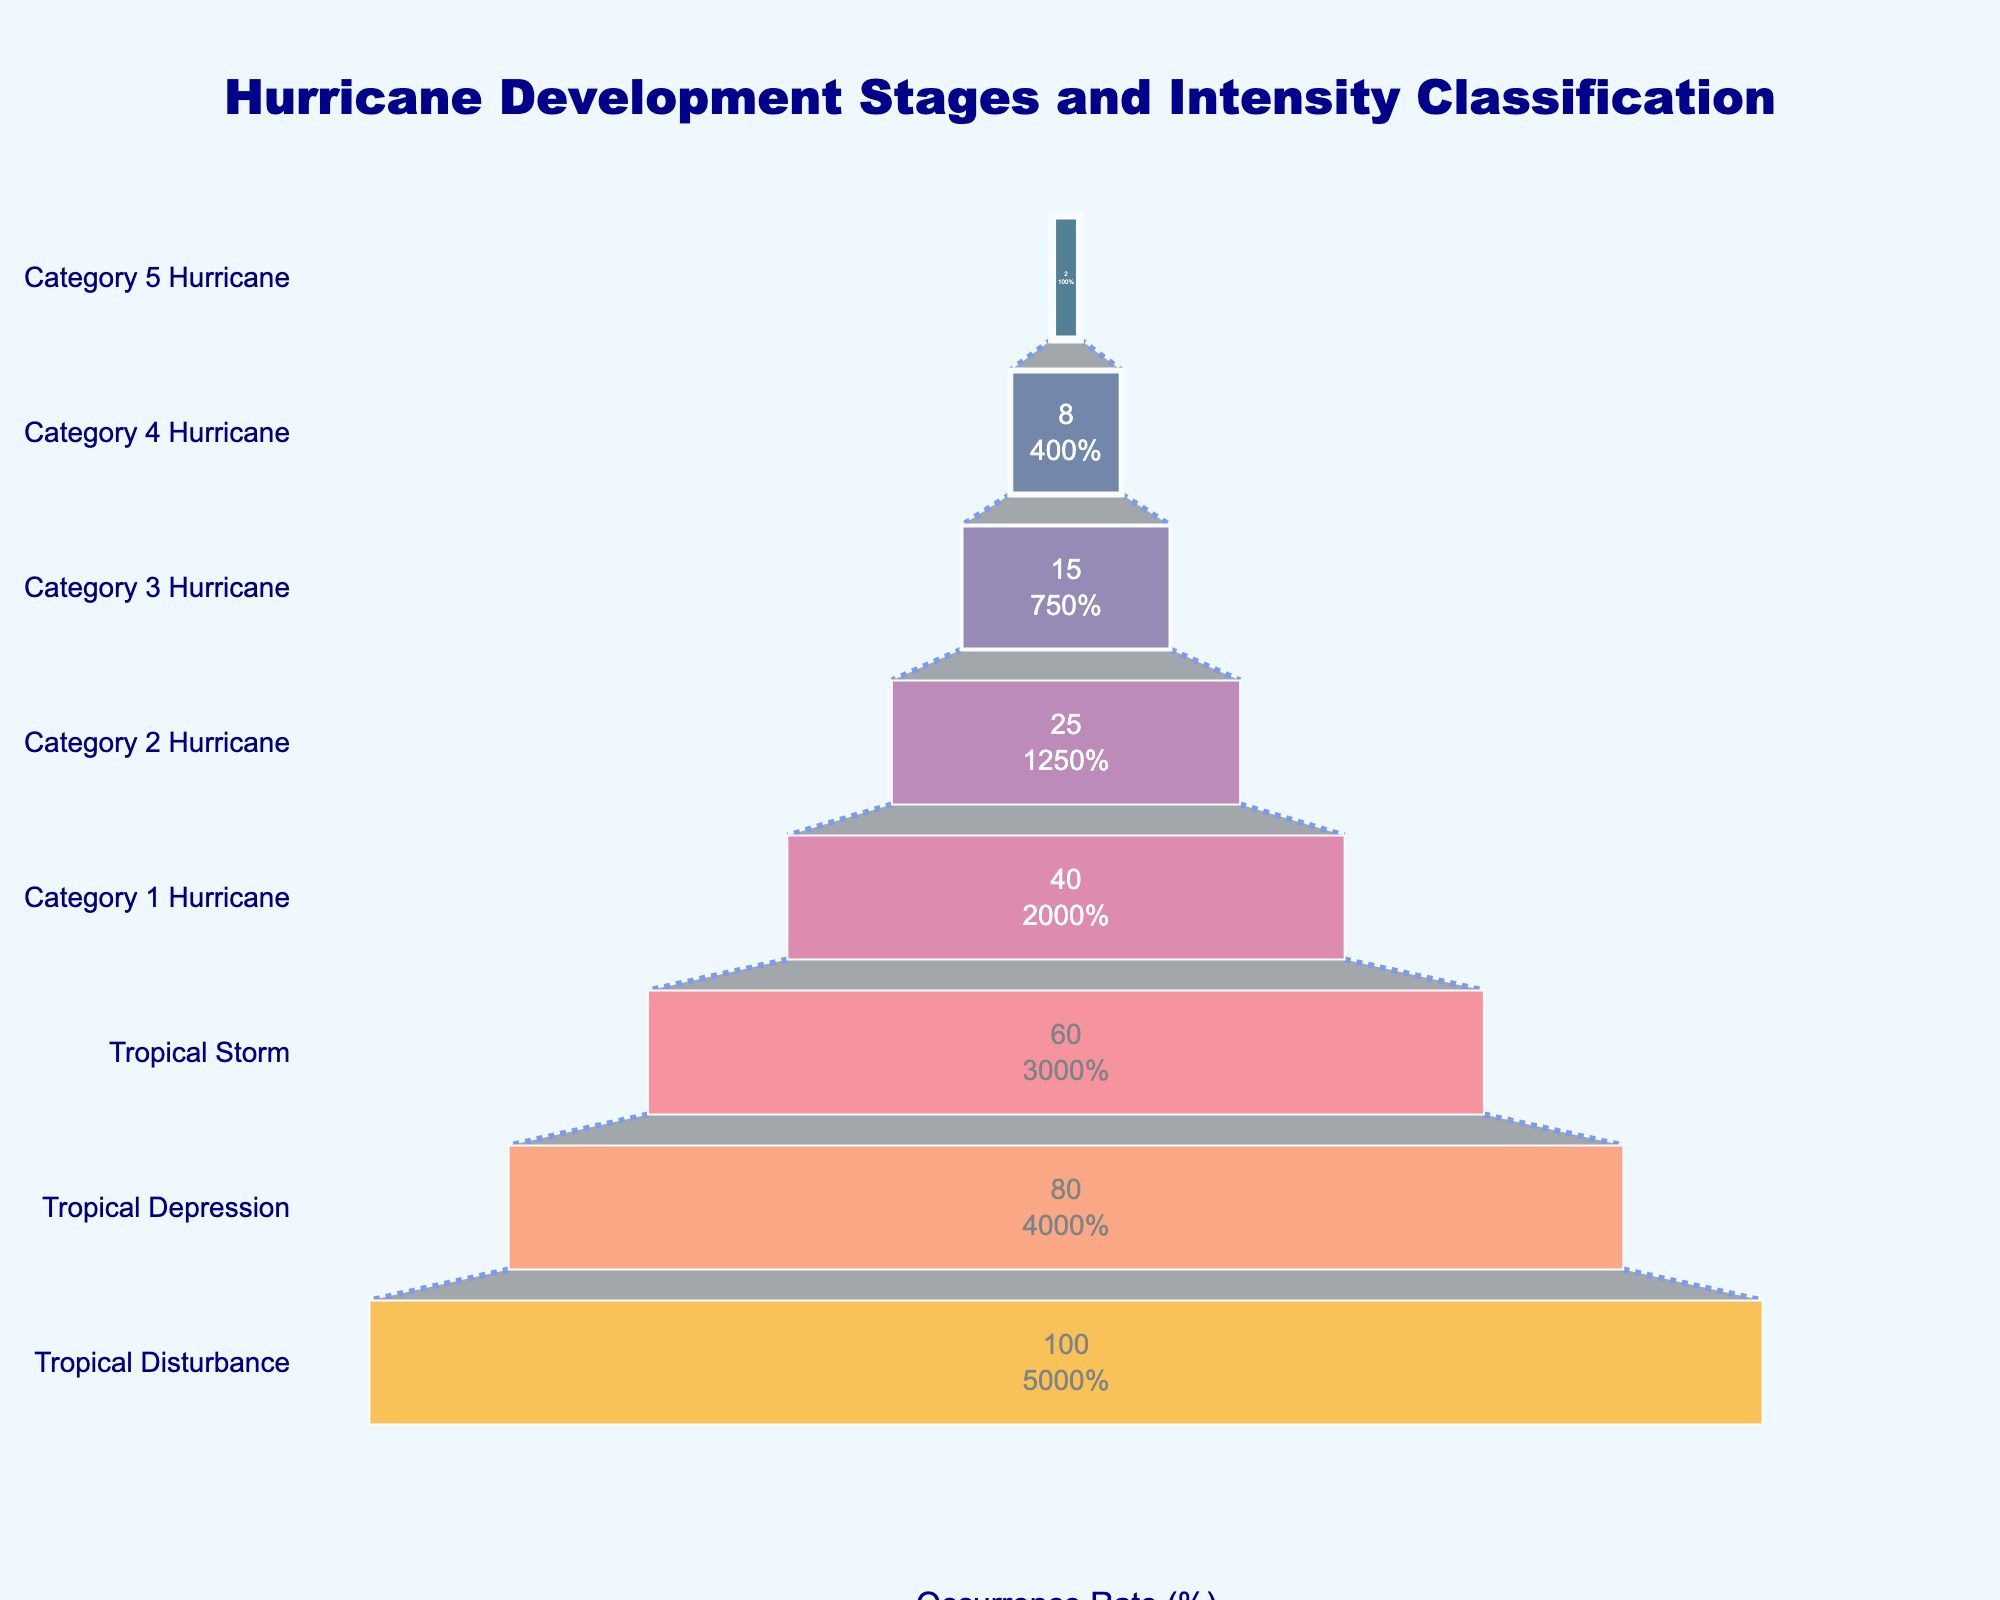What is the title of the chart? The title can be found at the top of the chart. It reads "Hurricane Development Stages and Intensity Classification" which indicates the context of the data presented.
Answer: Hurricane Development Stages and Intensity Classification What is the occurrence rate of a Category 3 Hurricane? By looking at the chart, find the bar labeled "Category 3 Hurricane" and observe the occurrence rate listed inside it.
Answer: 15% Which stage has the highest occurrence rate? The funnel chart's sections decrease in width from the top to the bottom. The widest section at the top represents the highest occurrence rate.
Answer: Tropical Disturbance How many stages are shown in the funnel chart? Count the number of distinct stages listed on the y-axis of the funnel chart.
Answer: 8 What is the difference in occurrence rate between a Tropical Storm and a Category 2 Hurricane? Find the occurrence rates for Tropical Storm (60%) and Category 2 Hurricane (25%), then subtract the smaller value from the larger one: 60 - 25 = 35.
Answer: 35% What is the combined occurrence rate for all hurricane categories (1 to 5)? Identify the occurrence rates for Category 1 (40), Category 2 (25), Category 3 (15), Category 4 (8), and Category 5 (2). Add these values together: 40 + 25 + 15 + 8 + 2 = 90.
Answer: 90% Which is more frequent, a Tropical Depression or a Category 4 Hurricane? Look at their occurrence rates. Tropical Depression has an occurrence rate of 80%, and Category 4 Hurricane has an occurrence rate of 8%. 80 > 8.
Answer: Tropical Depression How does the occurrence rate of a Tropical Storm compare to a Category 3 Hurricane? Compare the rates. Tropical Storm has a rate of 60%, and Category 3 Hurricane has a rate of 15%. Therefore, a Tropical Storm is more frequent.
Answer: Tropical Storm What is the ratio of occurrence rates between Category 1 Hurricanes and Category 5 Hurricanes? Divide the occurrence rate of Category 1 Hurricanes (40%) by that of Category 5 Hurricanes (2%): 40 / 2 = 20.
Answer: 20 Is there a significant drop in occurrence rate between Tropical Storm and Category 1 Hurricane stages? Compare the rates: Tropical Storm (60%) and Category 1 Hurricane (40%). The drop is 60 - 40 = 20%, which is quite significant.
Answer: Yes 